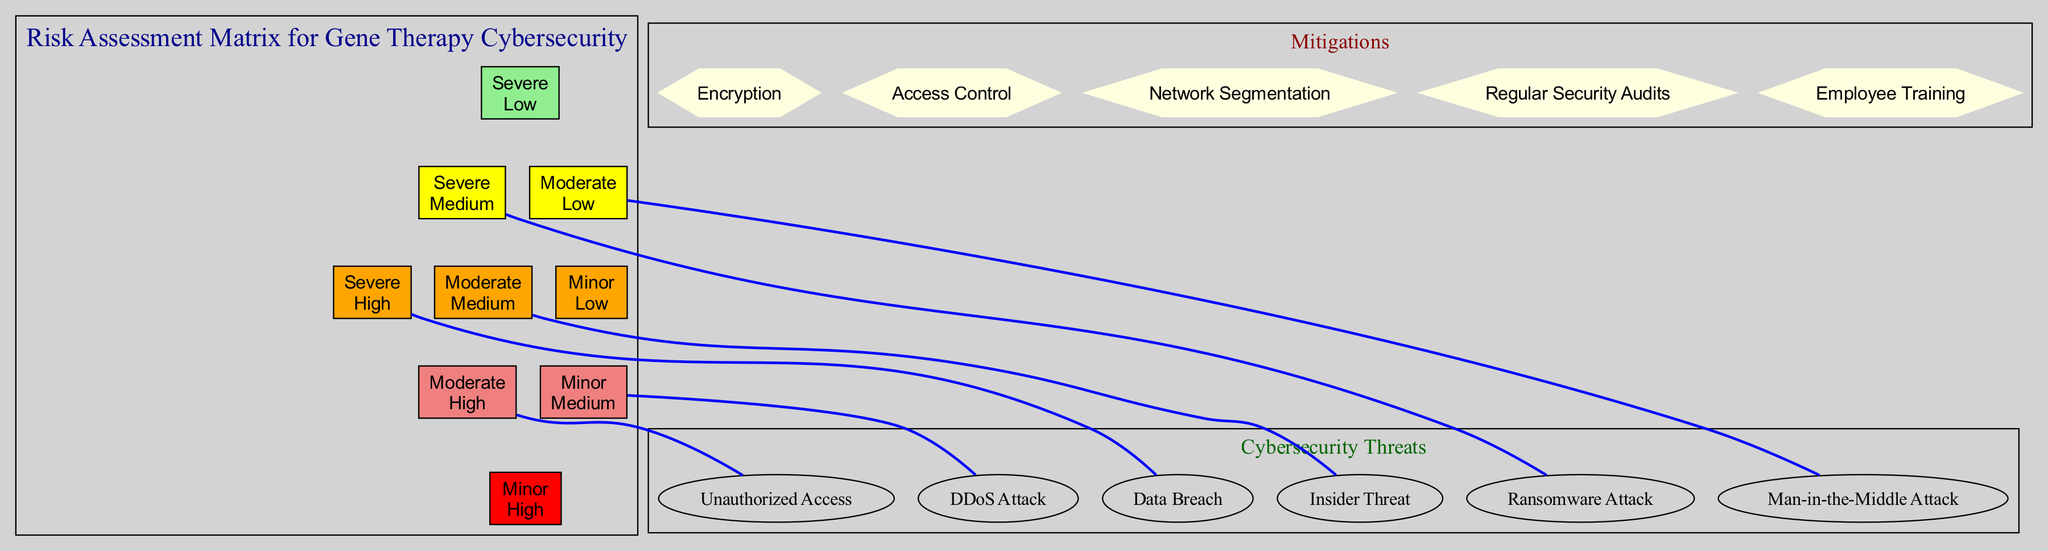What is the likelihood of a Data Breach? The diagram indicates that a Data Breach has a likelihood labeled as "High." This information can be directly found in the threat section of the matrix.
Answer: High How many threats are categorized with a "Severe" impact? By examining the threats listed in the diagram, two threats, namely "Data Breach" and "Ransomware Attack," are categorized with a "Severe" impact. Therefore, the total count is two.
Answer: 2 What mitigation strategy is suggested for addressing cybersecurity threats? The diagram lists several mitigation strategies, including "Encryption," "Access Control," "Network Segmentation," "Regular Security Audits," and "Employee Training." These strategies aim to reduce the risks associated with cybersecurity threats.
Answer: Encryption, Access Control, Network Segmentation, Regular Security Audits, Employee Training Which threat has a "Medium" likelihood and "Moderate" impact? The "Insider Threat" is identified as having a likelihood classified as "Medium" and an impact categorized as "Moderate," as seen in its specific threat entry in the diagram.
Answer: Insider Threat What color represents the combination of "High" likelihood and "Severe" impact? In the risk matrix, the combination of "High" likelihood and "Severe" impact is represented by the color "red." This can be deduced by locating the appropriate cell in the diagram corresponding to these labels.
Answer: Red Which threat connects to the category of "Minor" impact? The "DDoS Attack" is the threat that stems from the category of "Minor" impact, clearly indicated in its respective position within the matrix in the relationship to the likelihood it represents.
Answer: DDoS Attack How many nodes represent mitigations in the diagram? The diagram includes a total of five nodal representations for mitigations, as identified in the respective section labeled "Mitigations." Each strategy mentioned corresponds to a distinct node.
Answer: 5 Which threat has the highest likelihood and what is its impact? The "Data Breach" is shown as having the highest likelihood rated as "High" and also an impact categorized as "Severe," making it the most critical threat in the diagram.
Answer: Data Breach, Severe What is the relationship type between the "Ransomware Attack" and the "Severe" category? The diagram illustrates a direct connection (edge) from "Ransomware Attack" to the "Severe" impact category, indicating a strong relationship inherent to its categorization.
Answer: Direct connection 